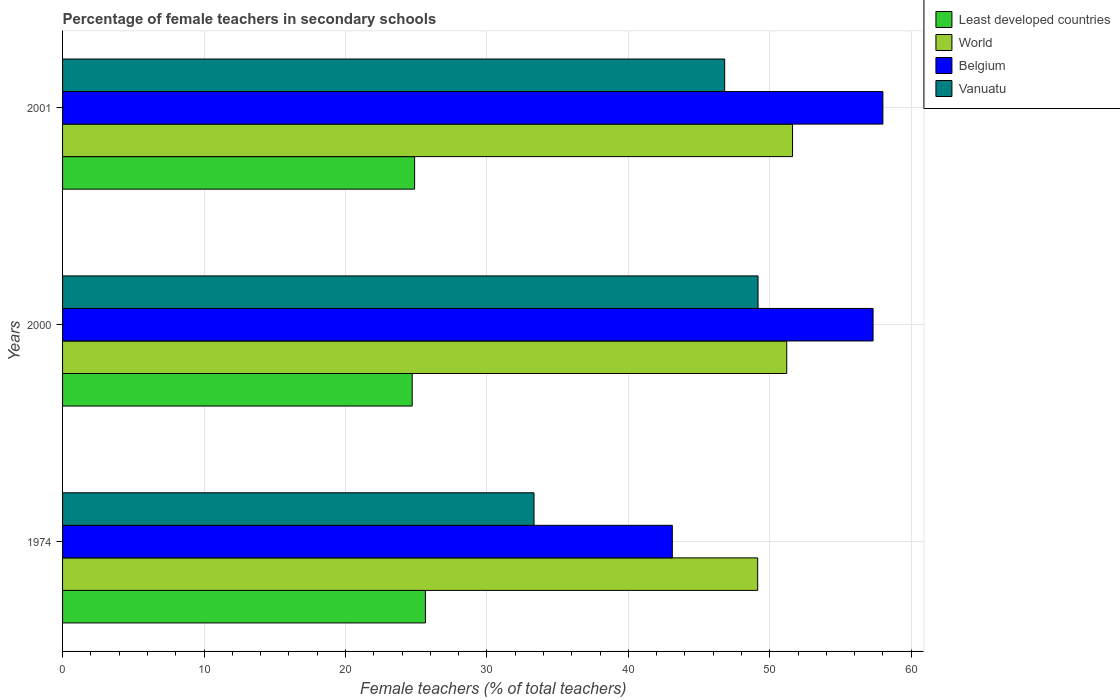How many different coloured bars are there?
Your answer should be compact. 4. How many groups of bars are there?
Keep it short and to the point. 3. Are the number of bars per tick equal to the number of legend labels?
Provide a short and direct response. Yes. Are the number of bars on each tick of the Y-axis equal?
Give a very brief answer. Yes. How many bars are there on the 3rd tick from the bottom?
Give a very brief answer. 4. In how many cases, is the number of bars for a given year not equal to the number of legend labels?
Provide a succinct answer. 0. What is the percentage of female teachers in Least developed countries in 1974?
Give a very brief answer. 25.66. Across all years, what is the maximum percentage of female teachers in Least developed countries?
Your answer should be compact. 25.66. Across all years, what is the minimum percentage of female teachers in Belgium?
Your answer should be compact. 43.11. In which year was the percentage of female teachers in Belgium minimum?
Provide a succinct answer. 1974. What is the total percentage of female teachers in Least developed countries in the graph?
Keep it short and to the point. 75.27. What is the difference between the percentage of female teachers in Belgium in 1974 and that in 2000?
Provide a succinct answer. -14.19. What is the difference between the percentage of female teachers in World in 2000 and the percentage of female teachers in Least developed countries in 1974?
Your response must be concise. 25.55. What is the average percentage of female teachers in World per year?
Ensure brevity in your answer.  50.65. In the year 2000, what is the difference between the percentage of female teachers in Vanuatu and percentage of female teachers in World?
Ensure brevity in your answer.  -2.03. What is the ratio of the percentage of female teachers in Vanuatu in 1974 to that in 2001?
Ensure brevity in your answer.  0.71. Is the difference between the percentage of female teachers in Vanuatu in 2000 and 2001 greater than the difference between the percentage of female teachers in World in 2000 and 2001?
Your response must be concise. Yes. What is the difference between the highest and the second highest percentage of female teachers in Belgium?
Ensure brevity in your answer.  0.7. What is the difference between the highest and the lowest percentage of female teachers in Belgium?
Provide a succinct answer. 14.89. In how many years, is the percentage of female teachers in Belgium greater than the average percentage of female teachers in Belgium taken over all years?
Offer a very short reply. 2. What does the 1st bar from the top in 2001 represents?
Provide a short and direct response. Vanuatu. What does the 4th bar from the bottom in 2001 represents?
Provide a short and direct response. Vanuatu. Is it the case that in every year, the sum of the percentage of female teachers in World and percentage of female teachers in Vanuatu is greater than the percentage of female teachers in Least developed countries?
Keep it short and to the point. Yes. How many bars are there?
Your answer should be compact. 12. Are all the bars in the graph horizontal?
Offer a very short reply. Yes. What is the difference between two consecutive major ticks on the X-axis?
Your response must be concise. 10. Does the graph contain grids?
Give a very brief answer. Yes. Where does the legend appear in the graph?
Your answer should be compact. Top right. What is the title of the graph?
Make the answer very short. Percentage of female teachers in secondary schools. Does "St. Vincent and the Grenadines" appear as one of the legend labels in the graph?
Provide a succinct answer. No. What is the label or title of the X-axis?
Your answer should be compact. Female teachers (% of total teachers). What is the label or title of the Y-axis?
Offer a very short reply. Years. What is the Female teachers (% of total teachers) in Least developed countries in 1974?
Offer a very short reply. 25.66. What is the Female teachers (% of total teachers) of World in 1974?
Offer a terse response. 49.15. What is the Female teachers (% of total teachers) of Belgium in 1974?
Ensure brevity in your answer.  43.11. What is the Female teachers (% of total teachers) in Vanuatu in 1974?
Ensure brevity in your answer.  33.33. What is the Female teachers (% of total teachers) in Least developed countries in 2000?
Provide a succinct answer. 24.72. What is the Female teachers (% of total teachers) in World in 2000?
Provide a short and direct response. 51.2. What is the Female teachers (% of total teachers) of Belgium in 2000?
Your response must be concise. 57.31. What is the Female teachers (% of total teachers) of Vanuatu in 2000?
Give a very brief answer. 49.17. What is the Female teachers (% of total teachers) in Least developed countries in 2001?
Ensure brevity in your answer.  24.89. What is the Female teachers (% of total teachers) of World in 2001?
Offer a terse response. 51.61. What is the Female teachers (% of total teachers) in Belgium in 2001?
Your answer should be very brief. 58. What is the Female teachers (% of total teachers) of Vanuatu in 2001?
Provide a short and direct response. 46.81. Across all years, what is the maximum Female teachers (% of total teachers) in Least developed countries?
Give a very brief answer. 25.66. Across all years, what is the maximum Female teachers (% of total teachers) in World?
Your answer should be compact. 51.61. Across all years, what is the maximum Female teachers (% of total teachers) in Belgium?
Your answer should be very brief. 58. Across all years, what is the maximum Female teachers (% of total teachers) of Vanuatu?
Give a very brief answer. 49.17. Across all years, what is the minimum Female teachers (% of total teachers) of Least developed countries?
Give a very brief answer. 24.72. Across all years, what is the minimum Female teachers (% of total teachers) of World?
Keep it short and to the point. 49.15. Across all years, what is the minimum Female teachers (% of total teachers) in Belgium?
Provide a succinct answer. 43.11. Across all years, what is the minimum Female teachers (% of total teachers) of Vanuatu?
Provide a succinct answer. 33.33. What is the total Female teachers (% of total teachers) in Least developed countries in the graph?
Give a very brief answer. 75.27. What is the total Female teachers (% of total teachers) of World in the graph?
Offer a terse response. 151.96. What is the total Female teachers (% of total teachers) of Belgium in the graph?
Provide a succinct answer. 158.42. What is the total Female teachers (% of total teachers) in Vanuatu in the graph?
Provide a short and direct response. 129.32. What is the difference between the Female teachers (% of total teachers) in Least developed countries in 1974 and that in 2000?
Your response must be concise. 0.93. What is the difference between the Female teachers (% of total teachers) in World in 1974 and that in 2000?
Give a very brief answer. -2.05. What is the difference between the Female teachers (% of total teachers) in Belgium in 1974 and that in 2000?
Your answer should be compact. -14.19. What is the difference between the Female teachers (% of total teachers) of Vanuatu in 1974 and that in 2000?
Your answer should be compact. -15.84. What is the difference between the Female teachers (% of total teachers) of Least developed countries in 1974 and that in 2001?
Your answer should be very brief. 0.76. What is the difference between the Female teachers (% of total teachers) in World in 1974 and that in 2001?
Your answer should be compact. -2.46. What is the difference between the Female teachers (% of total teachers) in Belgium in 1974 and that in 2001?
Make the answer very short. -14.89. What is the difference between the Female teachers (% of total teachers) in Vanuatu in 1974 and that in 2001?
Your response must be concise. -13.48. What is the difference between the Female teachers (% of total teachers) in Least developed countries in 2000 and that in 2001?
Your answer should be very brief. -0.17. What is the difference between the Female teachers (% of total teachers) of World in 2000 and that in 2001?
Provide a short and direct response. -0.41. What is the difference between the Female teachers (% of total teachers) of Belgium in 2000 and that in 2001?
Provide a short and direct response. -0.69. What is the difference between the Female teachers (% of total teachers) of Vanuatu in 2000 and that in 2001?
Provide a short and direct response. 2.36. What is the difference between the Female teachers (% of total teachers) of Least developed countries in 1974 and the Female teachers (% of total teachers) of World in 2000?
Give a very brief answer. -25.55. What is the difference between the Female teachers (% of total teachers) in Least developed countries in 1974 and the Female teachers (% of total teachers) in Belgium in 2000?
Your response must be concise. -31.65. What is the difference between the Female teachers (% of total teachers) of Least developed countries in 1974 and the Female teachers (% of total teachers) of Vanuatu in 2000?
Your answer should be very brief. -23.52. What is the difference between the Female teachers (% of total teachers) of World in 1974 and the Female teachers (% of total teachers) of Belgium in 2000?
Give a very brief answer. -8.16. What is the difference between the Female teachers (% of total teachers) of World in 1974 and the Female teachers (% of total teachers) of Vanuatu in 2000?
Give a very brief answer. -0.02. What is the difference between the Female teachers (% of total teachers) of Belgium in 1974 and the Female teachers (% of total teachers) of Vanuatu in 2000?
Your answer should be compact. -6.06. What is the difference between the Female teachers (% of total teachers) of Least developed countries in 1974 and the Female teachers (% of total teachers) of World in 2001?
Ensure brevity in your answer.  -25.96. What is the difference between the Female teachers (% of total teachers) of Least developed countries in 1974 and the Female teachers (% of total teachers) of Belgium in 2001?
Provide a succinct answer. -32.35. What is the difference between the Female teachers (% of total teachers) in Least developed countries in 1974 and the Female teachers (% of total teachers) in Vanuatu in 2001?
Your answer should be compact. -21.16. What is the difference between the Female teachers (% of total teachers) of World in 1974 and the Female teachers (% of total teachers) of Belgium in 2001?
Offer a terse response. -8.85. What is the difference between the Female teachers (% of total teachers) of World in 1974 and the Female teachers (% of total teachers) of Vanuatu in 2001?
Offer a very short reply. 2.33. What is the difference between the Female teachers (% of total teachers) of Belgium in 1974 and the Female teachers (% of total teachers) of Vanuatu in 2001?
Give a very brief answer. -3.7. What is the difference between the Female teachers (% of total teachers) in Least developed countries in 2000 and the Female teachers (% of total teachers) in World in 2001?
Provide a succinct answer. -26.89. What is the difference between the Female teachers (% of total teachers) in Least developed countries in 2000 and the Female teachers (% of total teachers) in Belgium in 2001?
Make the answer very short. -33.28. What is the difference between the Female teachers (% of total teachers) in Least developed countries in 2000 and the Female teachers (% of total teachers) in Vanuatu in 2001?
Offer a terse response. -22.09. What is the difference between the Female teachers (% of total teachers) in World in 2000 and the Female teachers (% of total teachers) in Belgium in 2001?
Provide a short and direct response. -6.8. What is the difference between the Female teachers (% of total teachers) in World in 2000 and the Female teachers (% of total teachers) in Vanuatu in 2001?
Offer a very short reply. 4.39. What is the difference between the Female teachers (% of total teachers) of Belgium in 2000 and the Female teachers (% of total teachers) of Vanuatu in 2001?
Your response must be concise. 10.49. What is the average Female teachers (% of total teachers) of Least developed countries per year?
Your response must be concise. 25.09. What is the average Female teachers (% of total teachers) in World per year?
Offer a very short reply. 50.65. What is the average Female teachers (% of total teachers) in Belgium per year?
Give a very brief answer. 52.81. What is the average Female teachers (% of total teachers) in Vanuatu per year?
Keep it short and to the point. 43.11. In the year 1974, what is the difference between the Female teachers (% of total teachers) in Least developed countries and Female teachers (% of total teachers) in World?
Provide a succinct answer. -23.49. In the year 1974, what is the difference between the Female teachers (% of total teachers) of Least developed countries and Female teachers (% of total teachers) of Belgium?
Provide a succinct answer. -17.46. In the year 1974, what is the difference between the Female teachers (% of total teachers) in Least developed countries and Female teachers (% of total teachers) in Vanuatu?
Offer a terse response. -7.68. In the year 1974, what is the difference between the Female teachers (% of total teachers) of World and Female teachers (% of total teachers) of Belgium?
Provide a short and direct response. 6.04. In the year 1974, what is the difference between the Female teachers (% of total teachers) in World and Female teachers (% of total teachers) in Vanuatu?
Make the answer very short. 15.81. In the year 1974, what is the difference between the Female teachers (% of total teachers) of Belgium and Female teachers (% of total teachers) of Vanuatu?
Your response must be concise. 9.78. In the year 2000, what is the difference between the Female teachers (% of total teachers) of Least developed countries and Female teachers (% of total teachers) of World?
Your response must be concise. -26.48. In the year 2000, what is the difference between the Female teachers (% of total teachers) in Least developed countries and Female teachers (% of total teachers) in Belgium?
Give a very brief answer. -32.58. In the year 2000, what is the difference between the Female teachers (% of total teachers) of Least developed countries and Female teachers (% of total teachers) of Vanuatu?
Your answer should be very brief. -24.45. In the year 2000, what is the difference between the Female teachers (% of total teachers) of World and Female teachers (% of total teachers) of Belgium?
Offer a very short reply. -6.1. In the year 2000, what is the difference between the Female teachers (% of total teachers) in World and Female teachers (% of total teachers) in Vanuatu?
Your answer should be compact. 2.03. In the year 2000, what is the difference between the Female teachers (% of total teachers) in Belgium and Female teachers (% of total teachers) in Vanuatu?
Your answer should be compact. 8.13. In the year 2001, what is the difference between the Female teachers (% of total teachers) of Least developed countries and Female teachers (% of total teachers) of World?
Your answer should be very brief. -26.72. In the year 2001, what is the difference between the Female teachers (% of total teachers) of Least developed countries and Female teachers (% of total teachers) of Belgium?
Your response must be concise. -33.11. In the year 2001, what is the difference between the Female teachers (% of total teachers) in Least developed countries and Female teachers (% of total teachers) in Vanuatu?
Your answer should be compact. -21.92. In the year 2001, what is the difference between the Female teachers (% of total teachers) in World and Female teachers (% of total teachers) in Belgium?
Give a very brief answer. -6.39. In the year 2001, what is the difference between the Female teachers (% of total teachers) of World and Female teachers (% of total teachers) of Vanuatu?
Keep it short and to the point. 4.8. In the year 2001, what is the difference between the Female teachers (% of total teachers) of Belgium and Female teachers (% of total teachers) of Vanuatu?
Your response must be concise. 11.19. What is the ratio of the Female teachers (% of total teachers) of Least developed countries in 1974 to that in 2000?
Your answer should be compact. 1.04. What is the ratio of the Female teachers (% of total teachers) of World in 1974 to that in 2000?
Keep it short and to the point. 0.96. What is the ratio of the Female teachers (% of total teachers) in Belgium in 1974 to that in 2000?
Your answer should be compact. 0.75. What is the ratio of the Female teachers (% of total teachers) in Vanuatu in 1974 to that in 2000?
Your answer should be compact. 0.68. What is the ratio of the Female teachers (% of total teachers) in Least developed countries in 1974 to that in 2001?
Your response must be concise. 1.03. What is the ratio of the Female teachers (% of total teachers) of World in 1974 to that in 2001?
Provide a short and direct response. 0.95. What is the ratio of the Female teachers (% of total teachers) in Belgium in 1974 to that in 2001?
Keep it short and to the point. 0.74. What is the ratio of the Female teachers (% of total teachers) in Vanuatu in 1974 to that in 2001?
Provide a succinct answer. 0.71. What is the ratio of the Female teachers (% of total teachers) in Vanuatu in 2000 to that in 2001?
Offer a very short reply. 1.05. What is the difference between the highest and the second highest Female teachers (% of total teachers) in Least developed countries?
Your answer should be compact. 0.76. What is the difference between the highest and the second highest Female teachers (% of total teachers) of World?
Give a very brief answer. 0.41. What is the difference between the highest and the second highest Female teachers (% of total teachers) in Belgium?
Offer a terse response. 0.69. What is the difference between the highest and the second highest Female teachers (% of total teachers) of Vanuatu?
Make the answer very short. 2.36. What is the difference between the highest and the lowest Female teachers (% of total teachers) of Least developed countries?
Offer a very short reply. 0.93. What is the difference between the highest and the lowest Female teachers (% of total teachers) of World?
Offer a terse response. 2.46. What is the difference between the highest and the lowest Female teachers (% of total teachers) in Belgium?
Keep it short and to the point. 14.89. What is the difference between the highest and the lowest Female teachers (% of total teachers) in Vanuatu?
Provide a short and direct response. 15.84. 